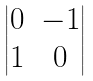Convert formula to latex. <formula><loc_0><loc_0><loc_500><loc_500>\begin{vmatrix} 0 & - 1 \\ 1 & 0 \end{vmatrix}</formula> 